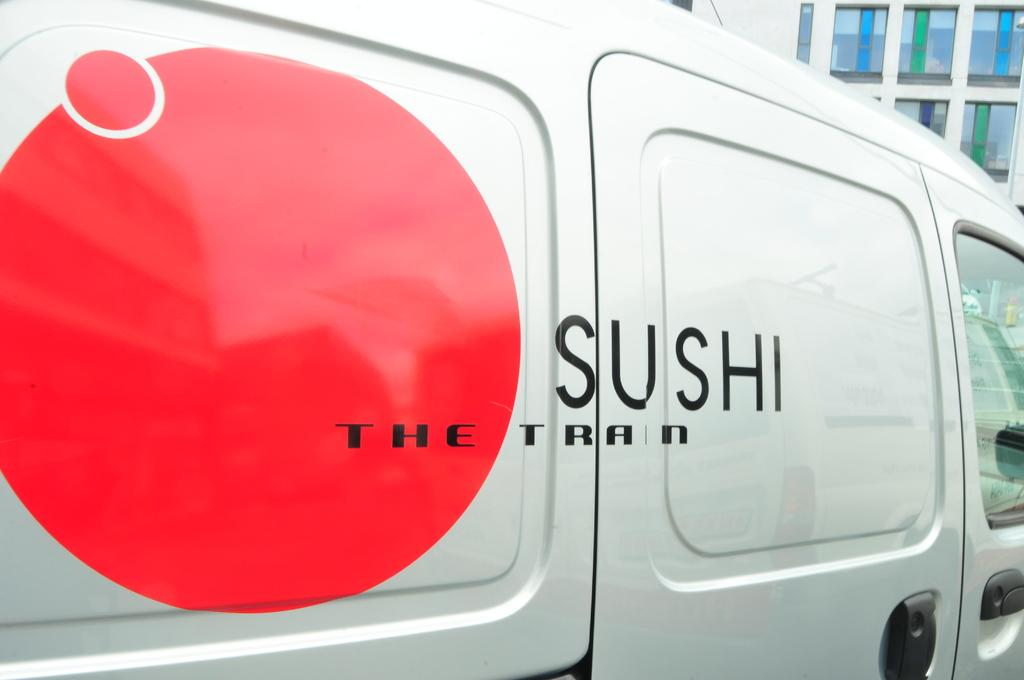What type of object is the main subject of the image? There is a vehicle in the image. What is the color of the vehicle? The vehicle is white in color. Are there any additional colors on the vehicle? Yes, the vehicle has red-colored paint on it. What can be seen in the background of the image? There is a building in the background of the image. What type of pie is being served in the image? There is no pie present in the image; it features a white vehicle with red paint and a building in the background. 